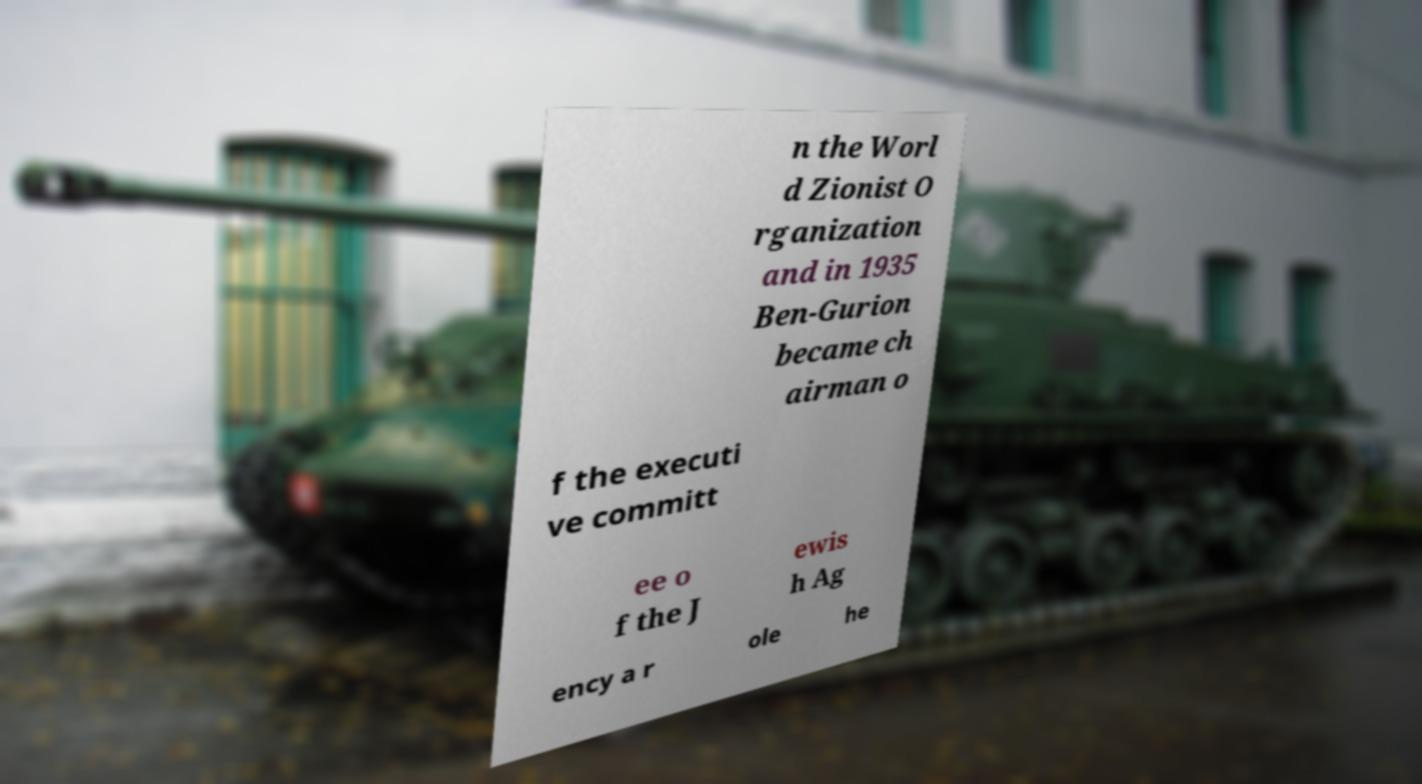Please read and relay the text visible in this image. What does it say? n the Worl d Zionist O rganization and in 1935 Ben-Gurion became ch airman o f the executi ve committ ee o f the J ewis h Ag ency a r ole he 